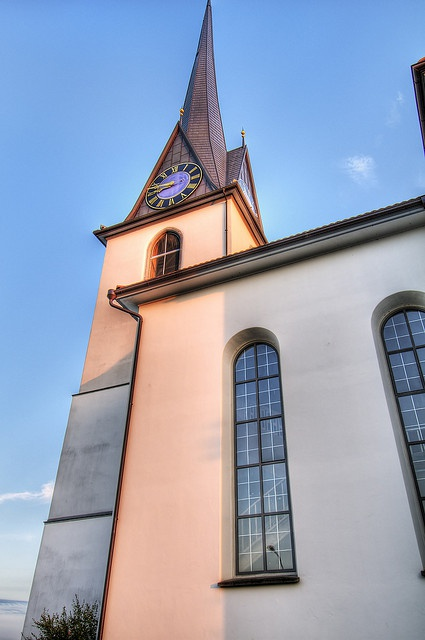Describe the objects in this image and their specific colors. I can see clock in lightblue, navy, violet, black, and tan tones and clock in lightblue, lavender, and darkgray tones in this image. 